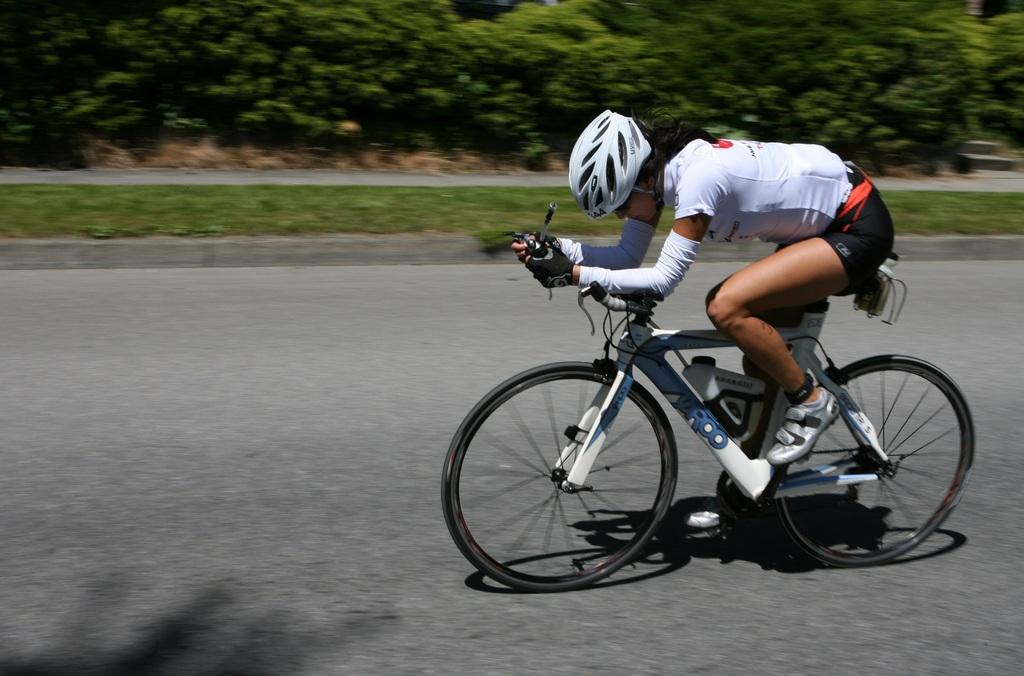Who is the main subject in the image? There is a girl in the image. Where is the girl located in the image? The girl is on the right side of the image. What is the girl doing in the image? The girl is cycling. What can be seen in the background of the image? There is greenery in the background of the image. What type of wine is the girl drinking while cycling in the image? There is no wine present in the image; the girl is cycling and there is no indication of her consuming any beverages. 